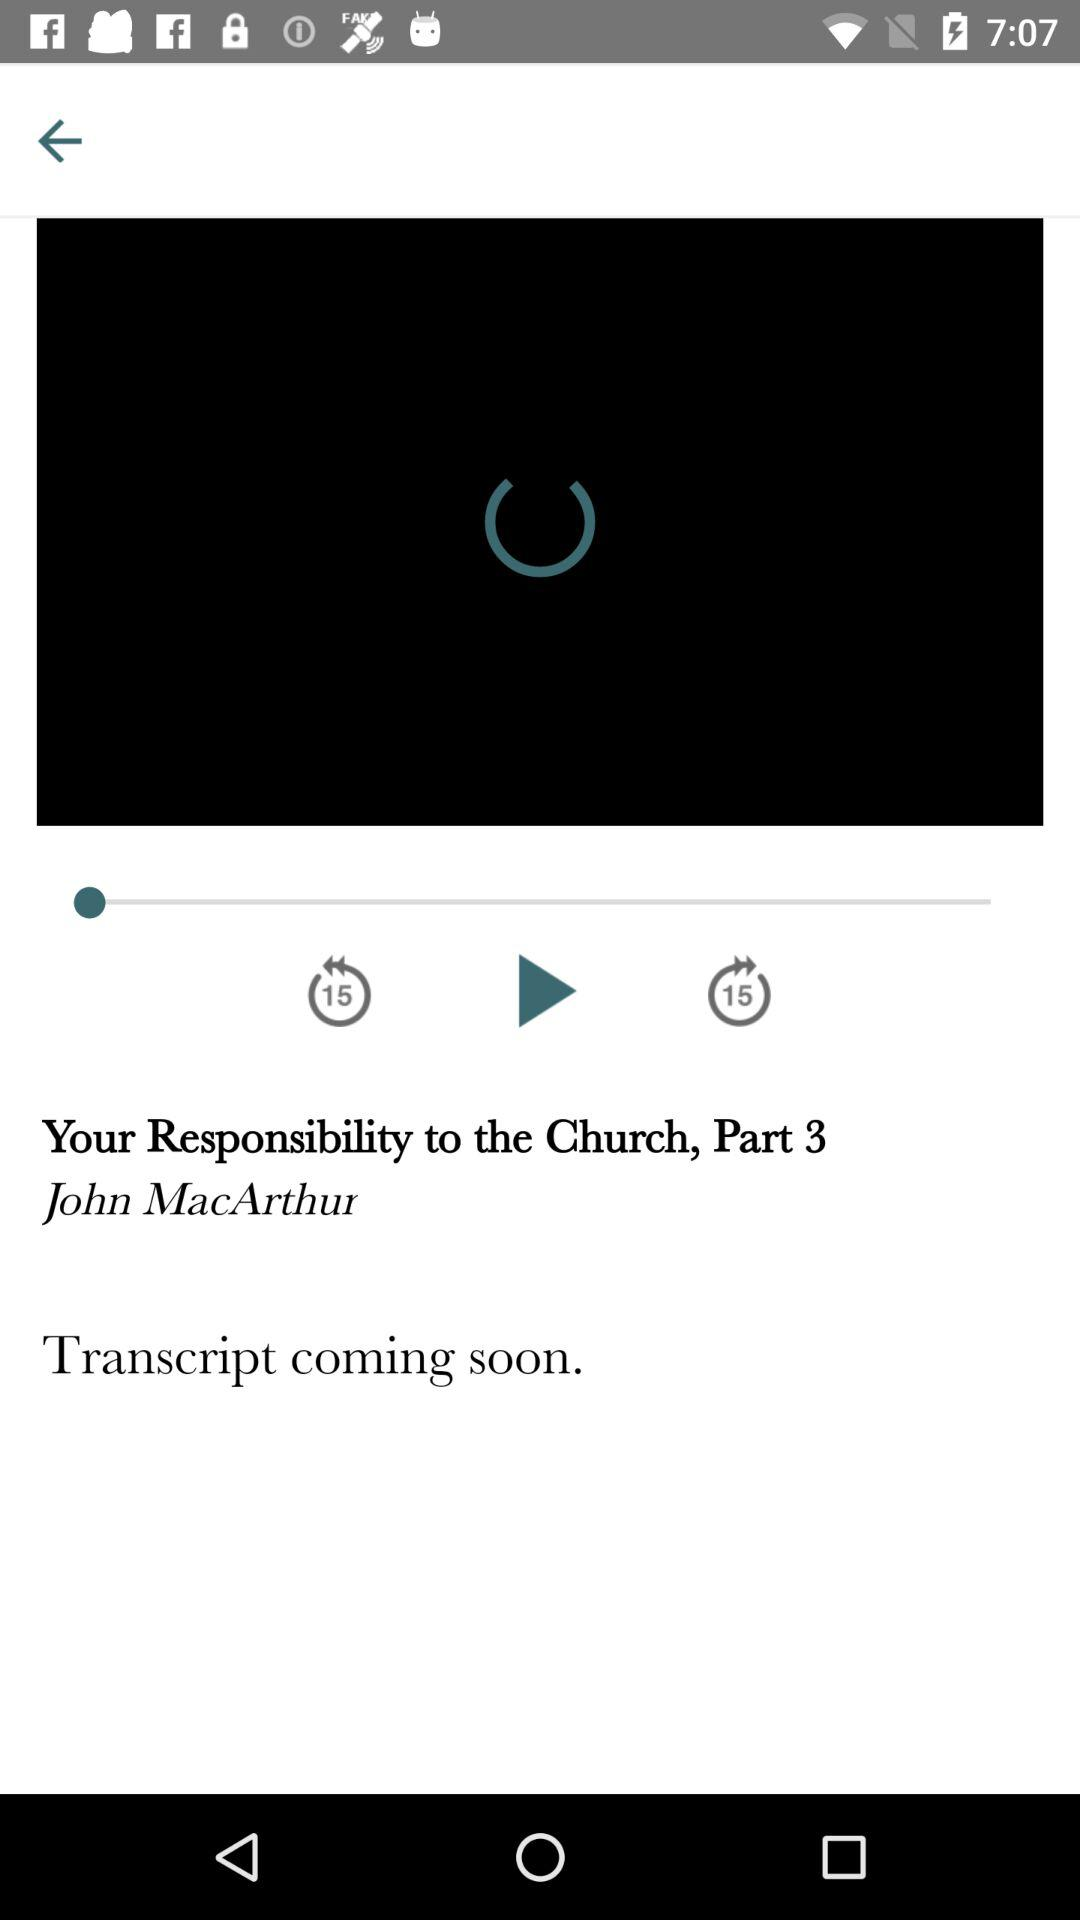What is the name of the video? The name of the video is "Your Responsibility to the Church, Part 3". 